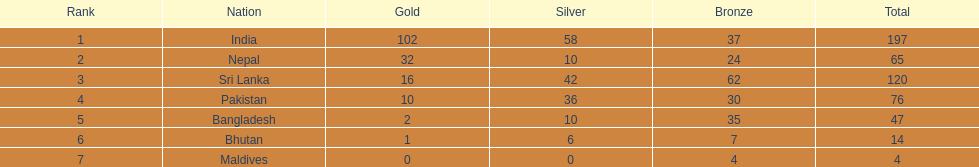What is the count of gold medals that nepal has won over pakistan? 22. Could you help me parse every detail presented in this table? {'header': ['Rank', 'Nation', 'Gold', 'Silver', 'Bronze', 'Total'], 'rows': [['1', 'India', '102', '58', '37', '197'], ['2', 'Nepal', '32', '10', '24', '65'], ['3', 'Sri Lanka', '16', '42', '62', '120'], ['4', 'Pakistan', '10', '36', '30', '76'], ['5', 'Bangladesh', '2', '10', '35', '47'], ['6', 'Bhutan', '1', '6', '7', '14'], ['7', 'Maldives', '0', '0', '4', '4']]} 